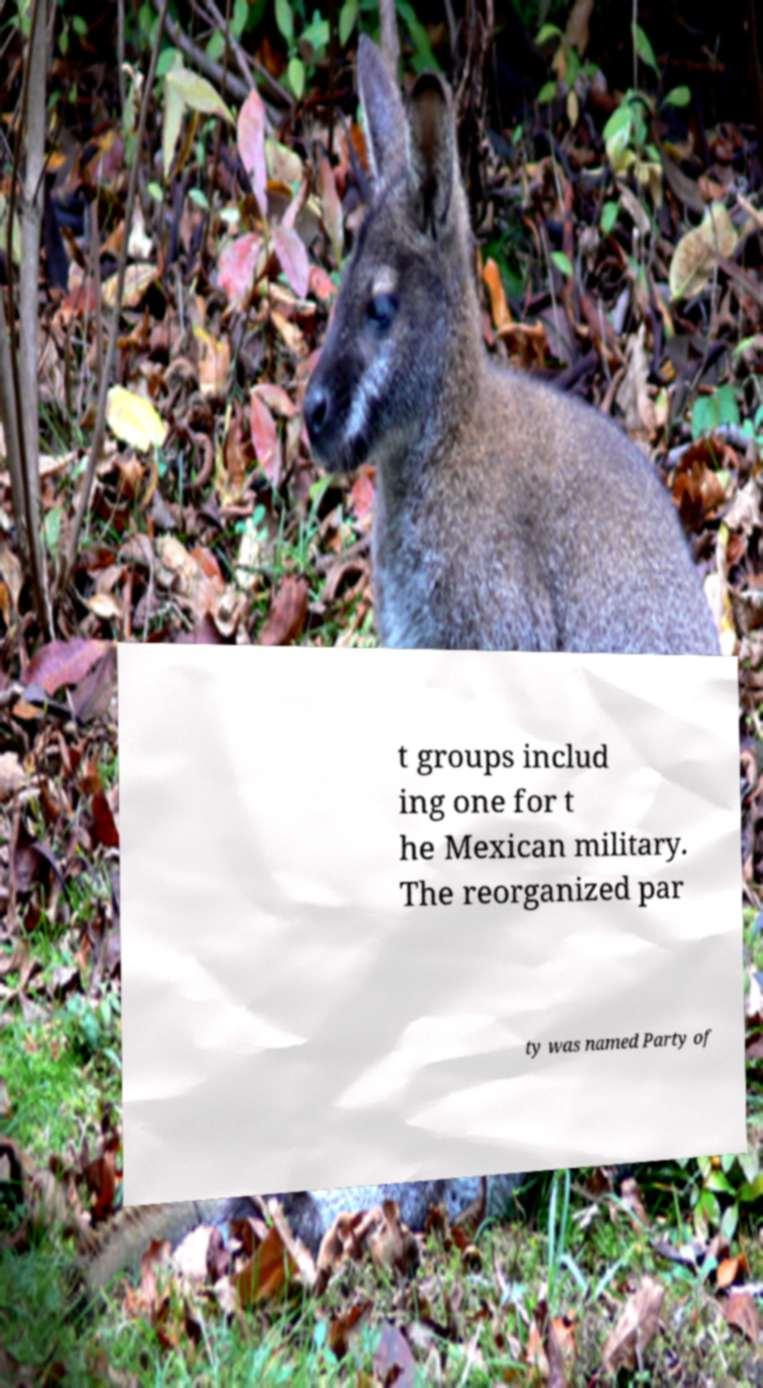Can you accurately transcribe the text from the provided image for me? t groups includ ing one for t he Mexican military. The reorganized par ty was named Party of 